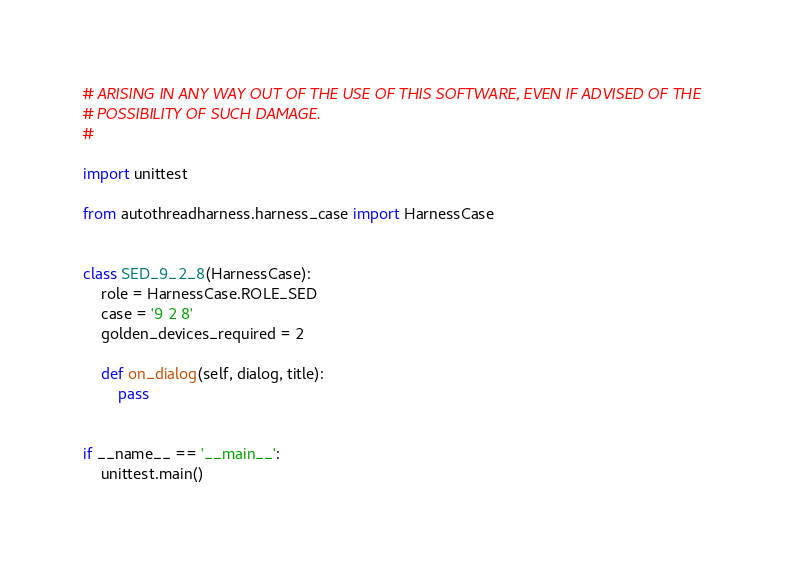<code> <loc_0><loc_0><loc_500><loc_500><_Python_># ARISING IN ANY WAY OUT OF THE USE OF THIS SOFTWARE, EVEN IF ADVISED OF THE
# POSSIBILITY OF SUCH DAMAGE.
#

import unittest

from autothreadharness.harness_case import HarnessCase


class SED_9_2_8(HarnessCase):
    role = HarnessCase.ROLE_SED
    case = '9 2 8'
    golden_devices_required = 2

    def on_dialog(self, dialog, title):
        pass


if __name__ == '__main__':
    unittest.main()
</code> 